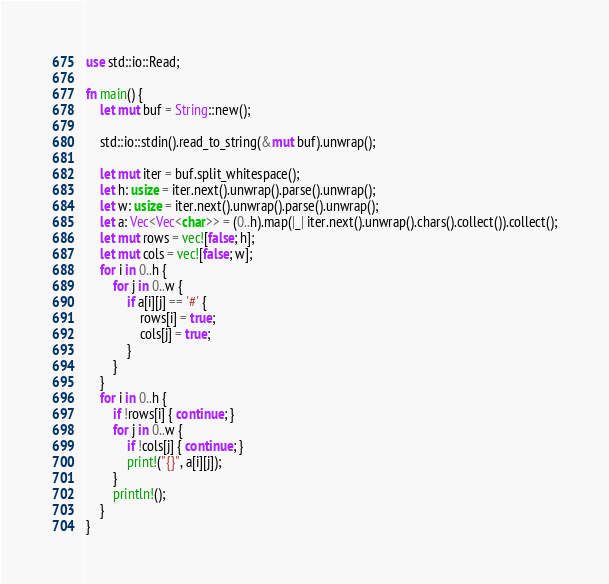<code> <loc_0><loc_0><loc_500><loc_500><_Rust_>use std::io::Read;

fn main() {
    let mut buf = String::new();

    std::io::stdin().read_to_string(&mut buf).unwrap();

    let mut iter = buf.split_whitespace();
    let h: usize = iter.next().unwrap().parse().unwrap();    
    let w: usize = iter.next().unwrap().parse().unwrap();    
    let a: Vec<Vec<char>> = (0..h).map(|_| iter.next().unwrap().chars().collect()).collect();
    let mut rows = vec![false; h];
    let mut cols = vec![false; w];
    for i in 0..h {
        for j in 0..w {
            if a[i][j] == '#' {
                rows[i] = true;
                cols[j] = true;
            }
        }
    }
    for i in 0..h {
        if !rows[i] { continue; }
        for j in 0..w {            
            if !cols[j] { continue; }
            print!("{}", a[i][j]);
        }
        println!();
    }
}

</code> 